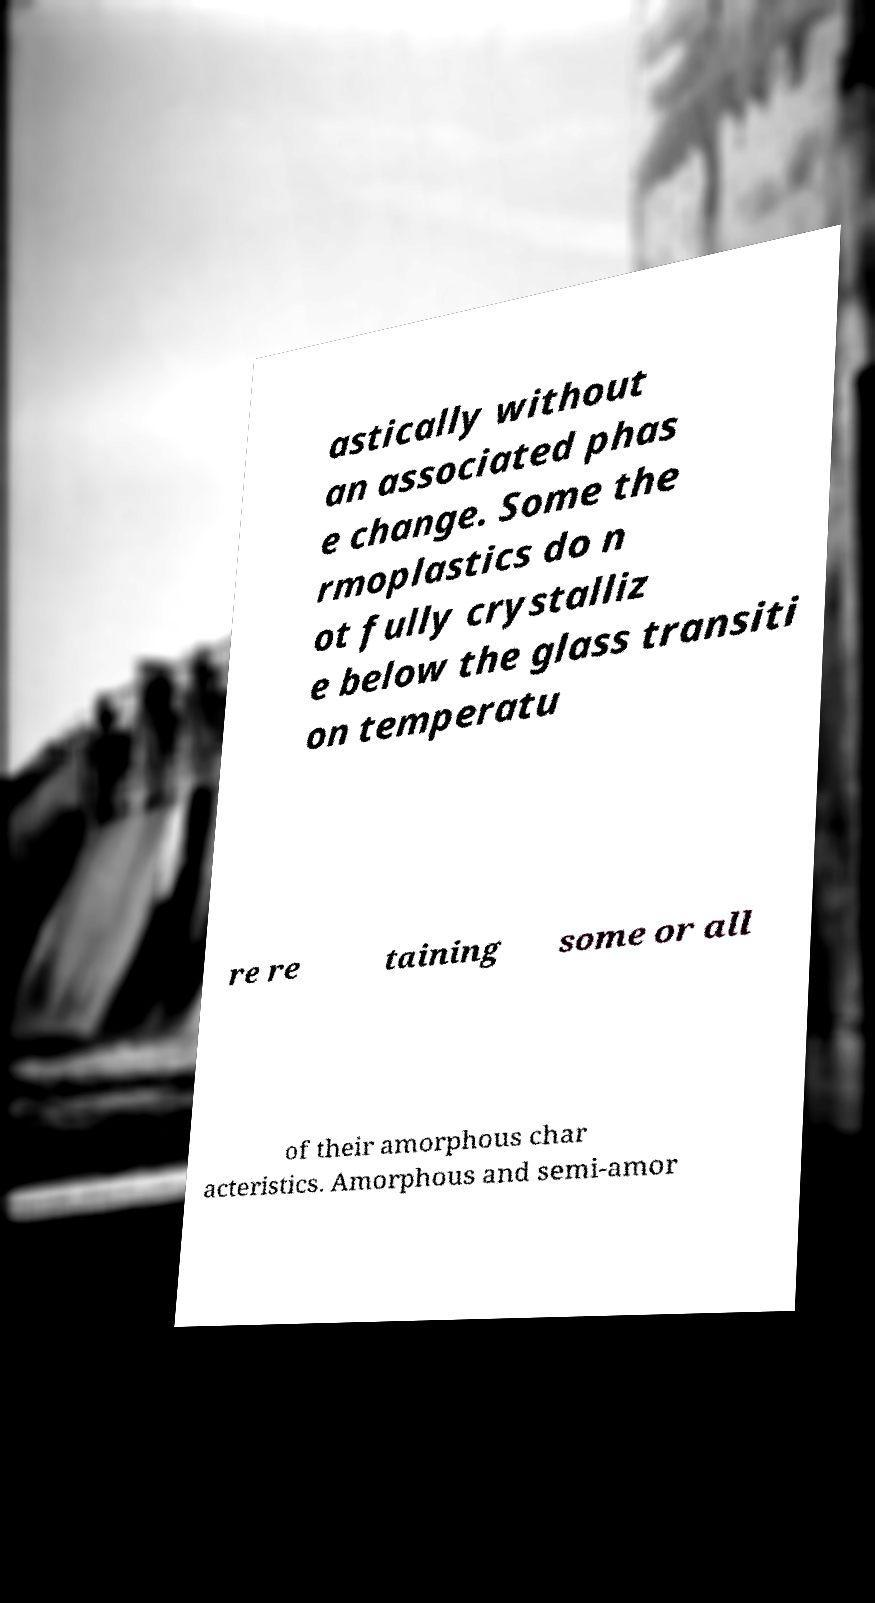Could you extract and type out the text from this image? astically without an associated phas e change. Some the rmoplastics do n ot fully crystalliz e below the glass transiti on temperatu re re taining some or all of their amorphous char acteristics. Amorphous and semi-amor 